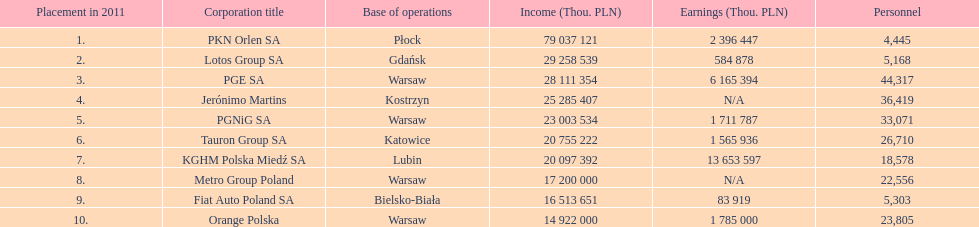Which company had the most revenue? PKN Orlen SA. 